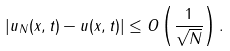Convert formula to latex. <formula><loc_0><loc_0><loc_500><loc_500>| u _ { N } ( x , t ) - u ( x , t ) | \leq O \left ( \frac { 1 } { \sqrt { N } } \right ) .</formula> 